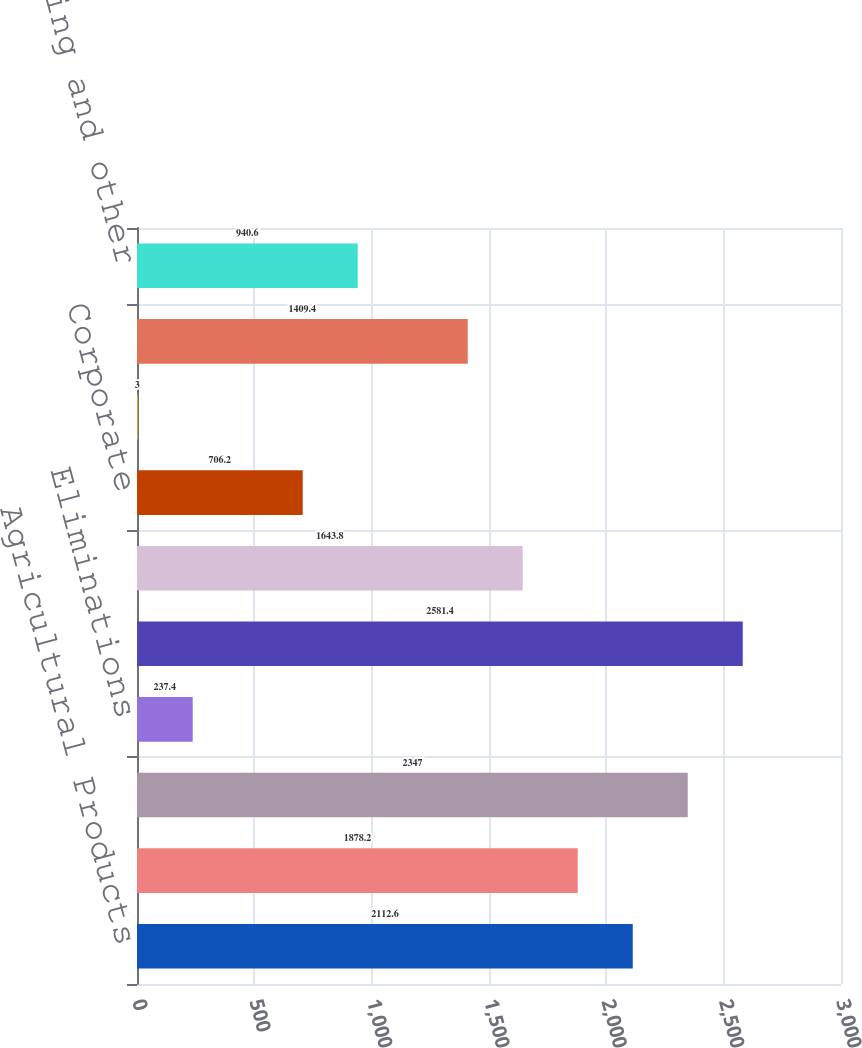<chart> <loc_0><loc_0><loc_500><loc_500><bar_chart><fcel>Agricultural Products<fcel>Specialty Chemicals<fcel>Industrial Chemicals<fcel>Eliminations<fcel>Total<fcel>Segment operating profit (1)<fcel>Corporate<fcel>Other income and (expense) net<fcel>Operating profit before the<fcel>Restructuring and other<nl><fcel>2112.6<fcel>1878.2<fcel>2347<fcel>237.4<fcel>2581.4<fcel>1643.8<fcel>706.2<fcel>3<fcel>1409.4<fcel>940.6<nl></chart> 